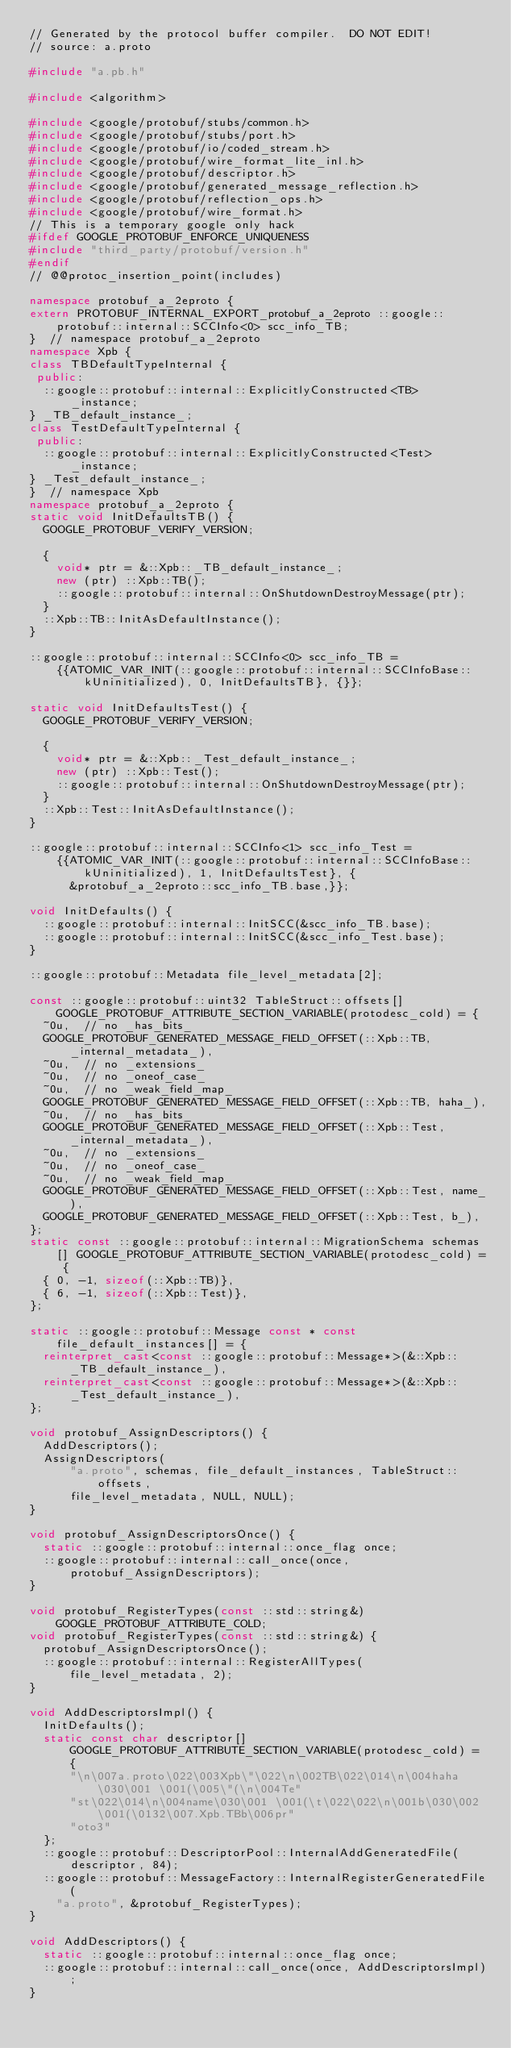<code> <loc_0><loc_0><loc_500><loc_500><_C++_>// Generated by the protocol buffer compiler.  DO NOT EDIT!
// source: a.proto

#include "a.pb.h"

#include <algorithm>

#include <google/protobuf/stubs/common.h>
#include <google/protobuf/stubs/port.h>
#include <google/protobuf/io/coded_stream.h>
#include <google/protobuf/wire_format_lite_inl.h>
#include <google/protobuf/descriptor.h>
#include <google/protobuf/generated_message_reflection.h>
#include <google/protobuf/reflection_ops.h>
#include <google/protobuf/wire_format.h>
// This is a temporary google only hack
#ifdef GOOGLE_PROTOBUF_ENFORCE_UNIQUENESS
#include "third_party/protobuf/version.h"
#endif
// @@protoc_insertion_point(includes)

namespace protobuf_a_2eproto {
extern PROTOBUF_INTERNAL_EXPORT_protobuf_a_2eproto ::google::protobuf::internal::SCCInfo<0> scc_info_TB;
}  // namespace protobuf_a_2eproto
namespace Xpb {
class TBDefaultTypeInternal {
 public:
  ::google::protobuf::internal::ExplicitlyConstructed<TB>
      _instance;
} _TB_default_instance_;
class TestDefaultTypeInternal {
 public:
  ::google::protobuf::internal::ExplicitlyConstructed<Test>
      _instance;
} _Test_default_instance_;
}  // namespace Xpb
namespace protobuf_a_2eproto {
static void InitDefaultsTB() {
  GOOGLE_PROTOBUF_VERIFY_VERSION;

  {
    void* ptr = &::Xpb::_TB_default_instance_;
    new (ptr) ::Xpb::TB();
    ::google::protobuf::internal::OnShutdownDestroyMessage(ptr);
  }
  ::Xpb::TB::InitAsDefaultInstance();
}

::google::protobuf::internal::SCCInfo<0> scc_info_TB =
    {{ATOMIC_VAR_INIT(::google::protobuf::internal::SCCInfoBase::kUninitialized), 0, InitDefaultsTB}, {}};

static void InitDefaultsTest() {
  GOOGLE_PROTOBUF_VERIFY_VERSION;

  {
    void* ptr = &::Xpb::_Test_default_instance_;
    new (ptr) ::Xpb::Test();
    ::google::protobuf::internal::OnShutdownDestroyMessage(ptr);
  }
  ::Xpb::Test::InitAsDefaultInstance();
}

::google::protobuf::internal::SCCInfo<1> scc_info_Test =
    {{ATOMIC_VAR_INIT(::google::protobuf::internal::SCCInfoBase::kUninitialized), 1, InitDefaultsTest}, {
      &protobuf_a_2eproto::scc_info_TB.base,}};

void InitDefaults() {
  ::google::protobuf::internal::InitSCC(&scc_info_TB.base);
  ::google::protobuf::internal::InitSCC(&scc_info_Test.base);
}

::google::protobuf::Metadata file_level_metadata[2];

const ::google::protobuf::uint32 TableStruct::offsets[] GOOGLE_PROTOBUF_ATTRIBUTE_SECTION_VARIABLE(protodesc_cold) = {
  ~0u,  // no _has_bits_
  GOOGLE_PROTOBUF_GENERATED_MESSAGE_FIELD_OFFSET(::Xpb::TB, _internal_metadata_),
  ~0u,  // no _extensions_
  ~0u,  // no _oneof_case_
  ~0u,  // no _weak_field_map_
  GOOGLE_PROTOBUF_GENERATED_MESSAGE_FIELD_OFFSET(::Xpb::TB, haha_),
  ~0u,  // no _has_bits_
  GOOGLE_PROTOBUF_GENERATED_MESSAGE_FIELD_OFFSET(::Xpb::Test, _internal_metadata_),
  ~0u,  // no _extensions_
  ~0u,  // no _oneof_case_
  ~0u,  // no _weak_field_map_
  GOOGLE_PROTOBUF_GENERATED_MESSAGE_FIELD_OFFSET(::Xpb::Test, name_),
  GOOGLE_PROTOBUF_GENERATED_MESSAGE_FIELD_OFFSET(::Xpb::Test, b_),
};
static const ::google::protobuf::internal::MigrationSchema schemas[] GOOGLE_PROTOBUF_ATTRIBUTE_SECTION_VARIABLE(protodesc_cold) = {
  { 0, -1, sizeof(::Xpb::TB)},
  { 6, -1, sizeof(::Xpb::Test)},
};

static ::google::protobuf::Message const * const file_default_instances[] = {
  reinterpret_cast<const ::google::protobuf::Message*>(&::Xpb::_TB_default_instance_),
  reinterpret_cast<const ::google::protobuf::Message*>(&::Xpb::_Test_default_instance_),
};

void protobuf_AssignDescriptors() {
  AddDescriptors();
  AssignDescriptors(
      "a.proto", schemas, file_default_instances, TableStruct::offsets,
      file_level_metadata, NULL, NULL);
}

void protobuf_AssignDescriptorsOnce() {
  static ::google::protobuf::internal::once_flag once;
  ::google::protobuf::internal::call_once(once, protobuf_AssignDescriptors);
}

void protobuf_RegisterTypes(const ::std::string&) GOOGLE_PROTOBUF_ATTRIBUTE_COLD;
void protobuf_RegisterTypes(const ::std::string&) {
  protobuf_AssignDescriptorsOnce();
  ::google::protobuf::internal::RegisterAllTypes(file_level_metadata, 2);
}

void AddDescriptorsImpl() {
  InitDefaults();
  static const char descriptor[] GOOGLE_PROTOBUF_ATTRIBUTE_SECTION_VARIABLE(protodesc_cold) = {
      "\n\007a.proto\022\003Xpb\"\022\n\002TB\022\014\n\004haha\030\001 \001(\005\"(\n\004Te"
      "st\022\014\n\004name\030\001 \001(\t\022\022\n\001b\030\002 \001(\0132\007.Xpb.TBb\006pr"
      "oto3"
  };
  ::google::protobuf::DescriptorPool::InternalAddGeneratedFile(
      descriptor, 84);
  ::google::protobuf::MessageFactory::InternalRegisterGeneratedFile(
    "a.proto", &protobuf_RegisterTypes);
}

void AddDescriptors() {
  static ::google::protobuf::internal::once_flag once;
  ::google::protobuf::internal::call_once(once, AddDescriptorsImpl);
}</code> 